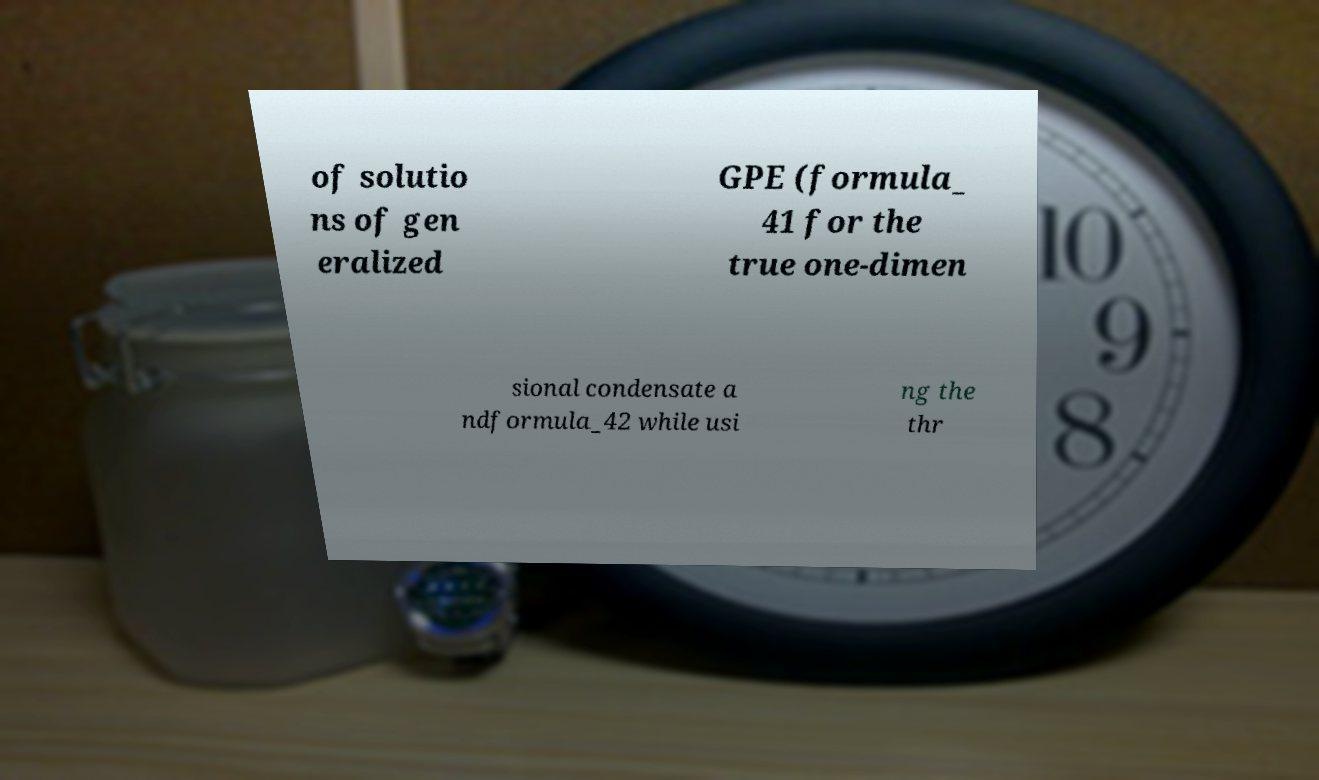Can you read and provide the text displayed in the image?This photo seems to have some interesting text. Can you extract and type it out for me? of solutio ns of gen eralized GPE (formula_ 41 for the true one-dimen sional condensate a ndformula_42 while usi ng the thr 